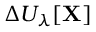Convert formula to latex. <formula><loc_0><loc_0><loc_500><loc_500>\Delta U _ { \lambda } [ X ]</formula> 